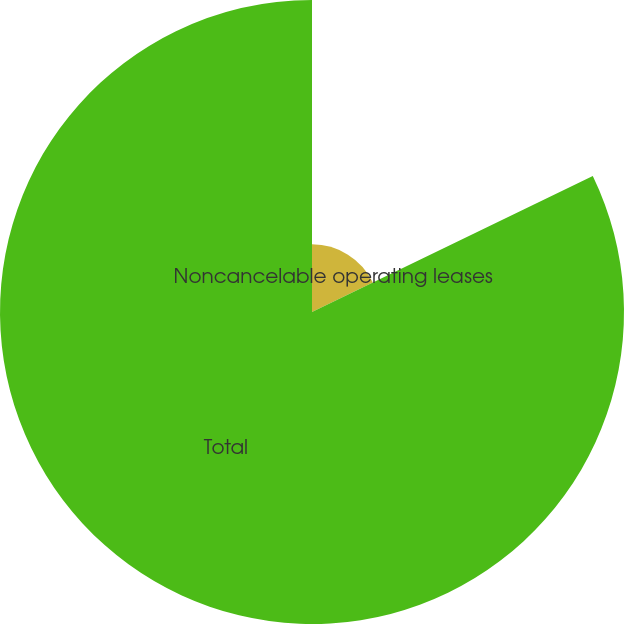Convert chart to OTSL. <chart><loc_0><loc_0><loc_500><loc_500><pie_chart><fcel>Noncancelable operating leases<fcel>Total<nl><fcel>17.82%<fcel>82.18%<nl></chart> 